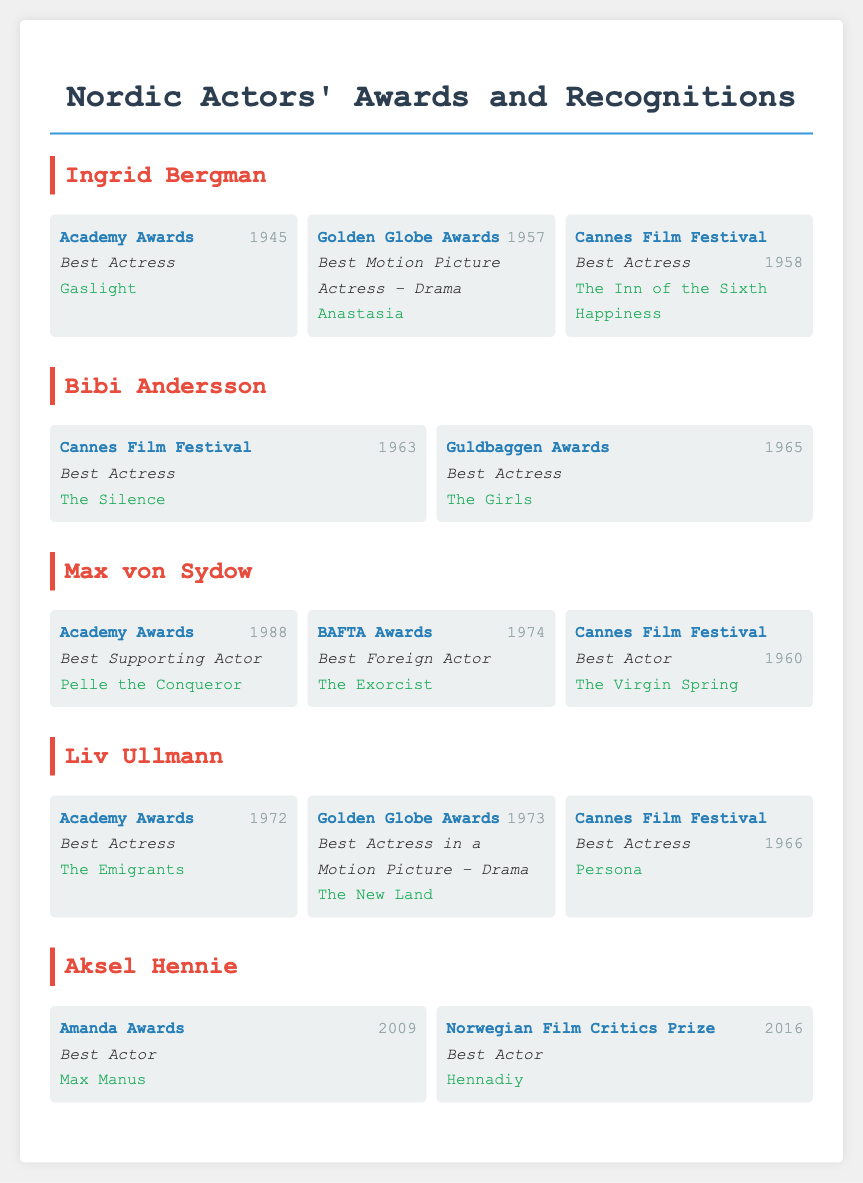What award did Ingrid Bergman win in 1945? The award Ingrid Bergman won in 1945 is the Academy Award for Best Actress for the film "Gaslight".
Answer: Academy Award for Best Actress Which film earned Bibi Andersson the Best Actress award at Cannes in 1963? The film that earned Bibi Andersson the Best Actress award at Cannes in 1963 is "The Silence".
Answer: The Silence How many awards did Max von Sydow win in total according to the document? Max von Sydow won three awards according to the document: Academy Awards, BAFTA Awards, and Cannes Film Festival.
Answer: Three What category did Liv Ullmann win at the Cannes Film Festival in 1966? The category Liv Ullmann won at the Cannes Film Festival in 1966 is Best Actress for the film "Persona".
Answer: Best Actress In which year did Aksel Hennie win the Amanda Award? Aksel Hennie won the Amanda Award in the year 2009 for the film "Max Manus".
Answer: 2009 Which actor has received recognition from both the Academy Awards and BAFTA Awards? The actor who has received recognition from both the Academy Awards and BAFTA Awards is Max von Sydow.
Answer: Max von Sydow What film did Liv Ullmann receive a Golden Globe nomination for in 1973? The film Liv Ullmann received a Golden Globe nomination for in 1973 is "The New Land".
Answer: The New Land At what ceremony did Bibi Andersson win her Best Actress award for "The Girls"? Bibi Andersson won her Best Actress award for "The Girls" at the Guldbaggen Awards.
Answer: Guldbaggen Awards 